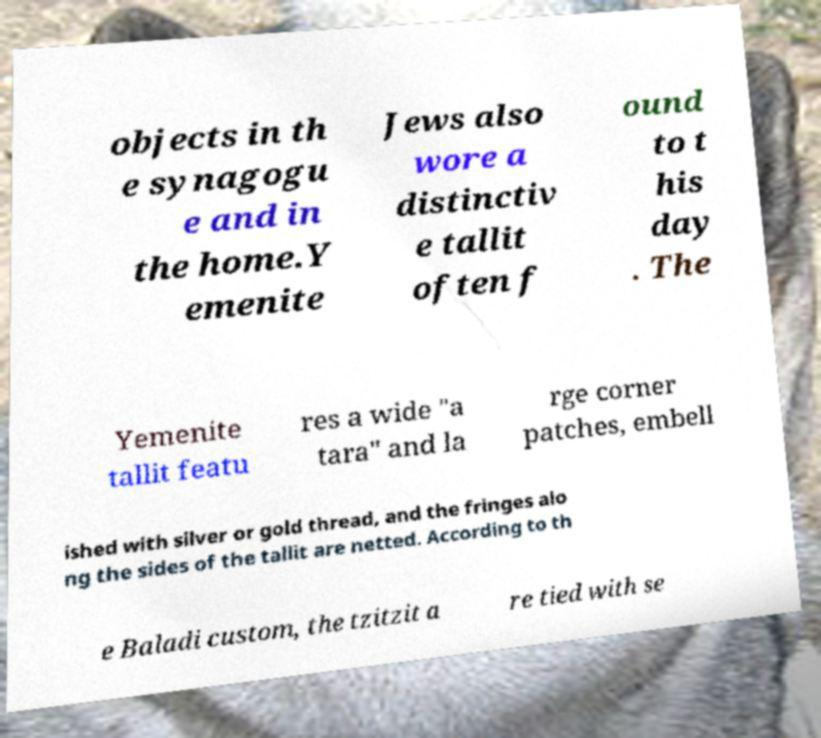There's text embedded in this image that I need extracted. Can you transcribe it verbatim? objects in th e synagogu e and in the home.Y emenite Jews also wore a distinctiv e tallit often f ound to t his day . The Yemenite tallit featu res a wide "a tara" and la rge corner patches, embell ished with silver or gold thread, and the fringes alo ng the sides of the tallit are netted. According to th e Baladi custom, the tzitzit a re tied with se 